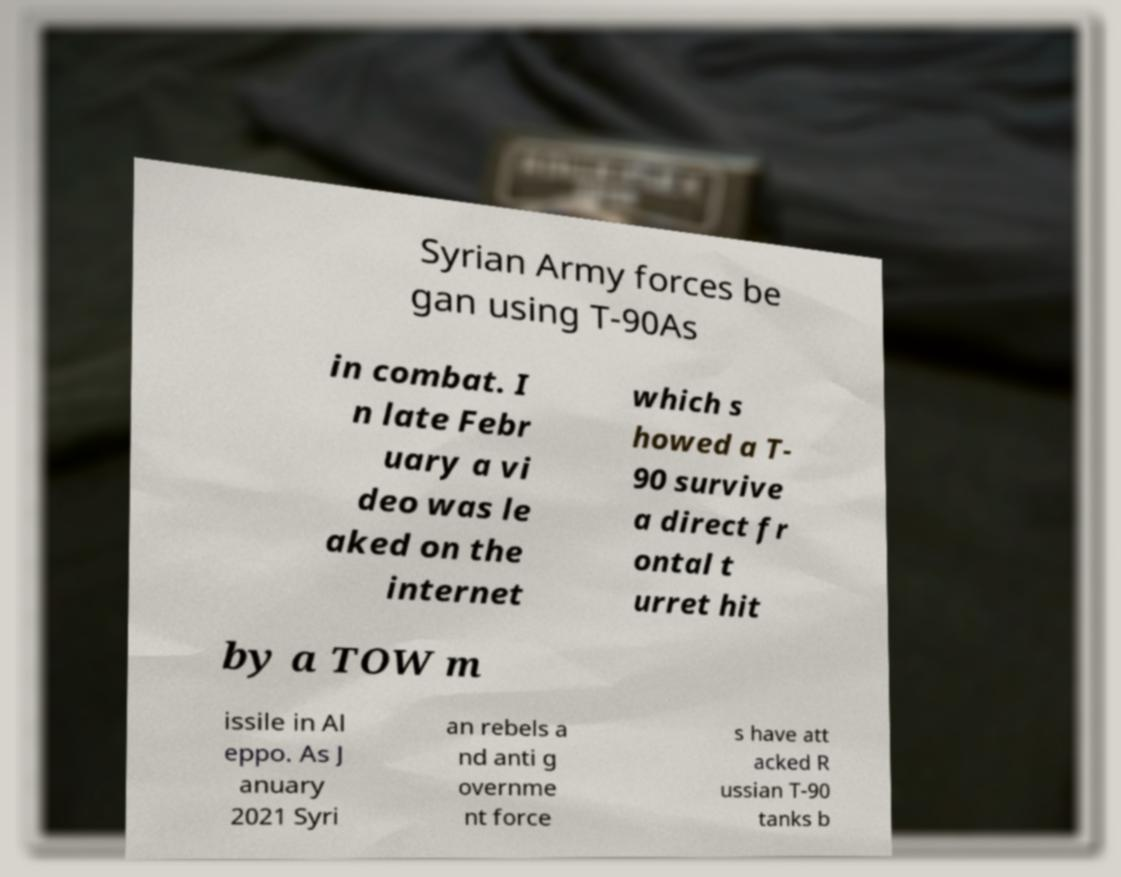Can you accurately transcribe the text from the provided image for me? Syrian Army forces be gan using T-90As in combat. I n late Febr uary a vi deo was le aked on the internet which s howed a T- 90 survive a direct fr ontal t urret hit by a TOW m issile in Al eppo. As J anuary 2021 Syri an rebels a nd anti g overnme nt force s have att acked R ussian T-90 tanks b 